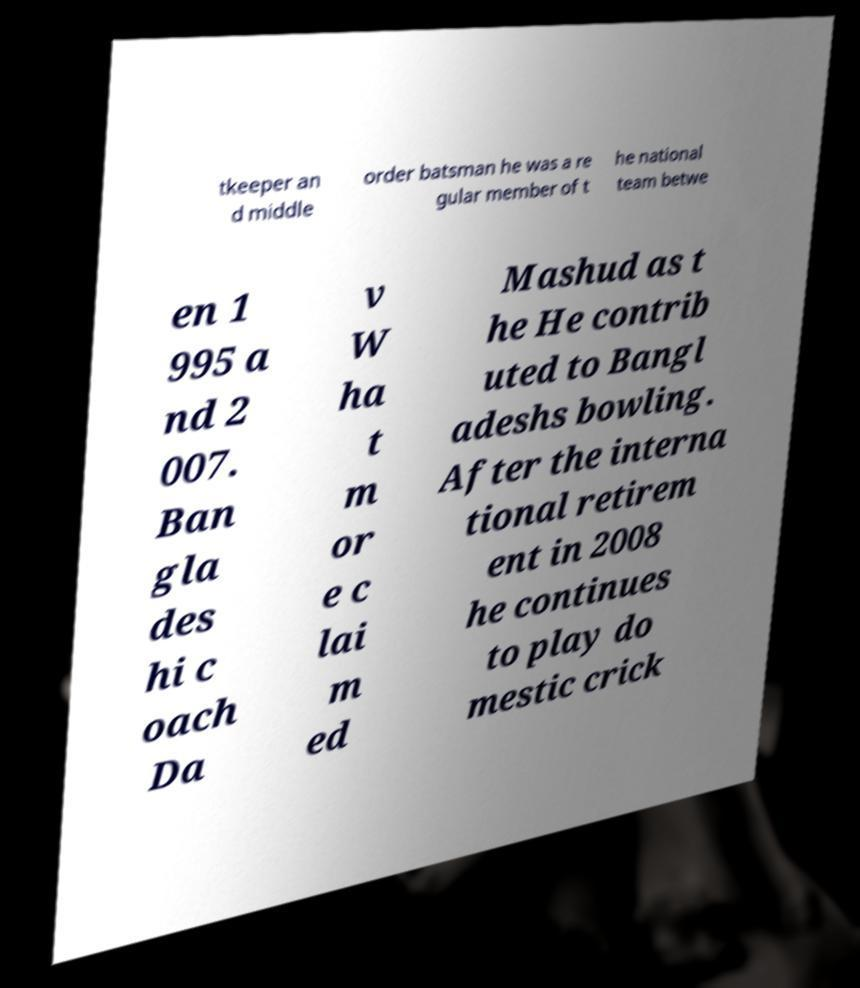For documentation purposes, I need the text within this image transcribed. Could you provide that? tkeeper an d middle order batsman he was a re gular member of t he national team betwe en 1 995 a nd 2 007. Ban gla des hi c oach Da v W ha t m or e c lai m ed Mashud as t he He contrib uted to Bangl adeshs bowling. After the interna tional retirem ent in 2008 he continues to play do mestic crick 